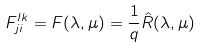Convert formula to latex. <formula><loc_0><loc_0><loc_500><loc_500>F ^ { l k } _ { j i } = F ( \lambda , \mu ) = \frac { 1 } { q } \hat { R } ( \lambda , \mu )</formula> 